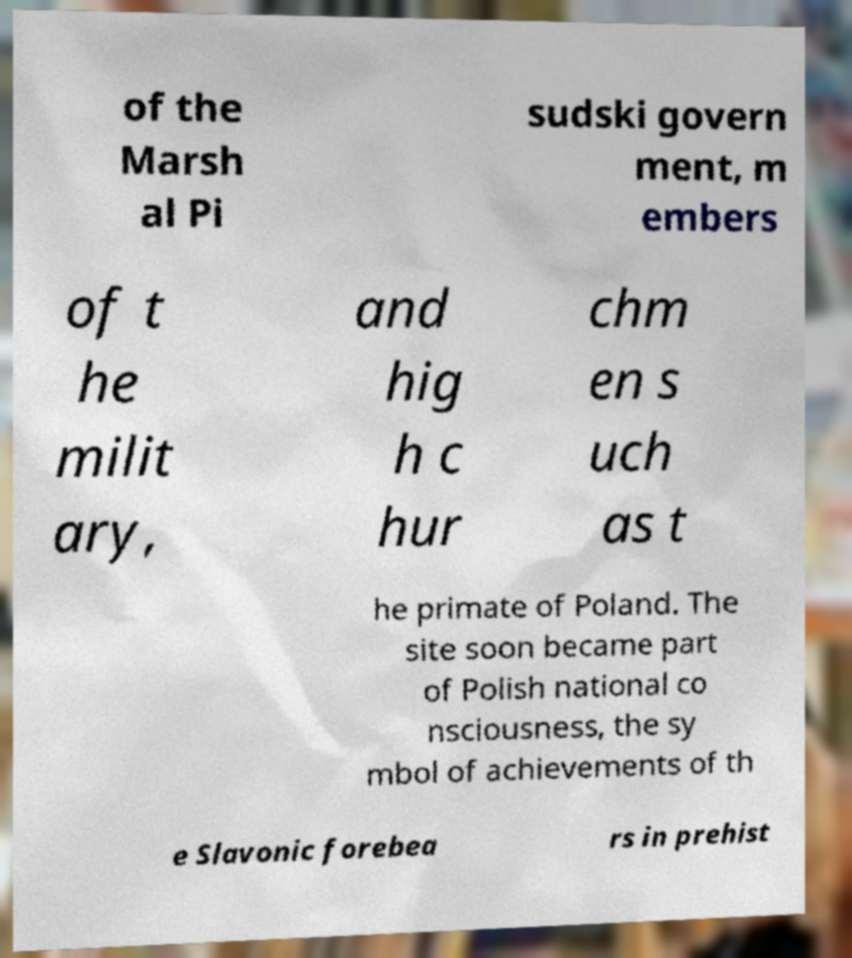There's text embedded in this image that I need extracted. Can you transcribe it verbatim? of the Marsh al Pi sudski govern ment, m embers of t he milit ary, and hig h c hur chm en s uch as t he primate of Poland. The site soon became part of Polish national co nsciousness, the sy mbol of achievements of th e Slavonic forebea rs in prehist 